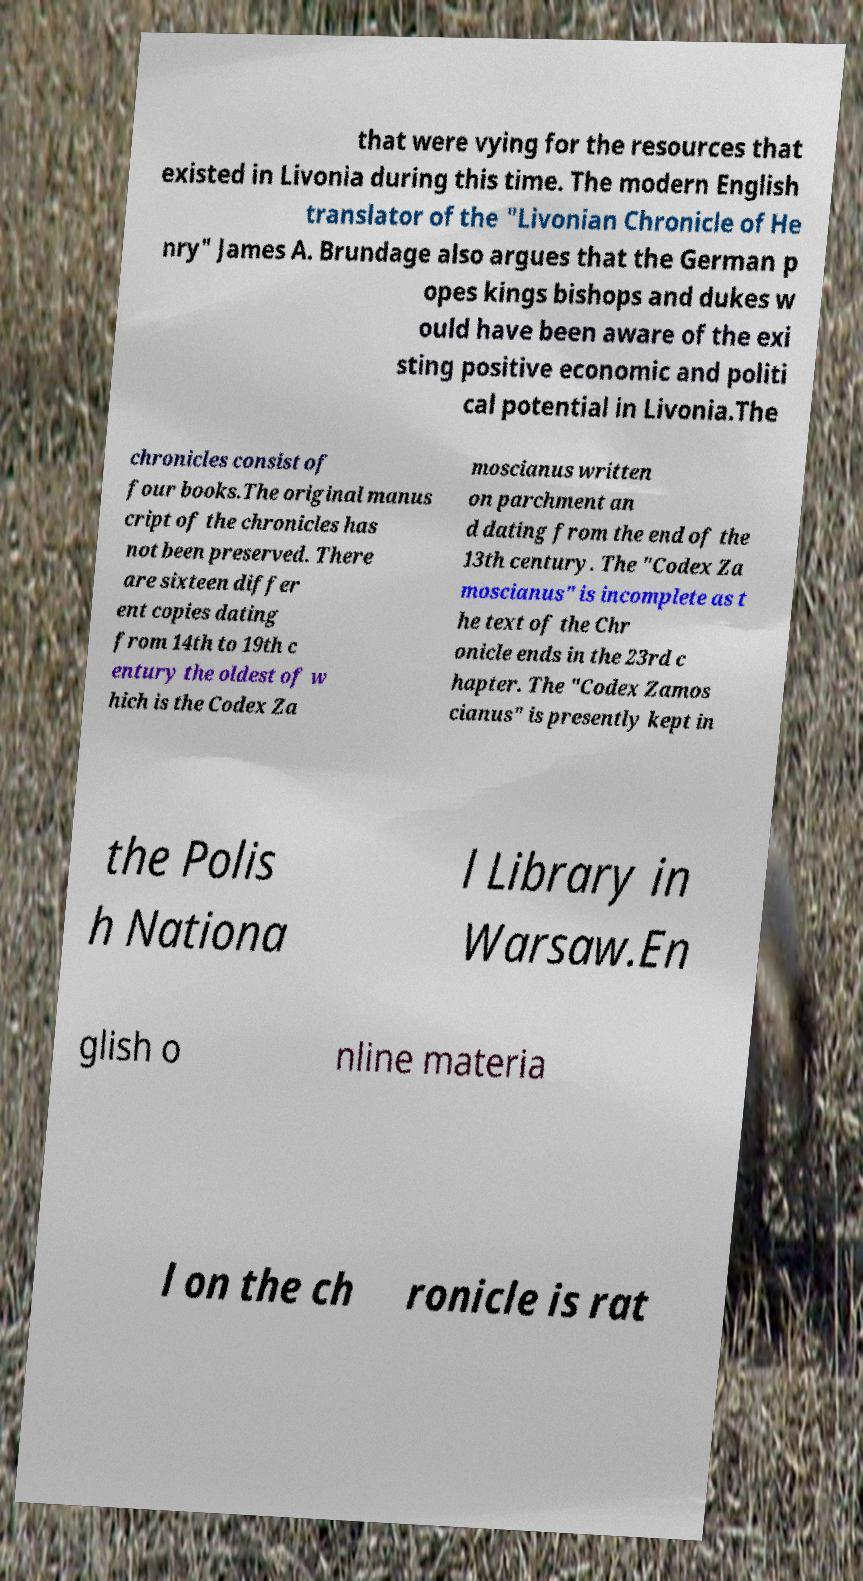I need the written content from this picture converted into text. Can you do that? that were vying for the resources that existed in Livonia during this time. The modern English translator of the "Livonian Chronicle of He nry" James A. Brundage also argues that the German p opes kings bishops and dukes w ould have been aware of the exi sting positive economic and politi cal potential in Livonia.The chronicles consist of four books.The original manus cript of the chronicles has not been preserved. There are sixteen differ ent copies dating from 14th to 19th c entury the oldest of w hich is the Codex Za moscianus written on parchment an d dating from the end of the 13th century. The "Codex Za moscianus" is incomplete as t he text of the Chr onicle ends in the 23rd c hapter. The "Codex Zamos cianus" is presently kept in the Polis h Nationa l Library in Warsaw.En glish o nline materia l on the ch ronicle is rat 